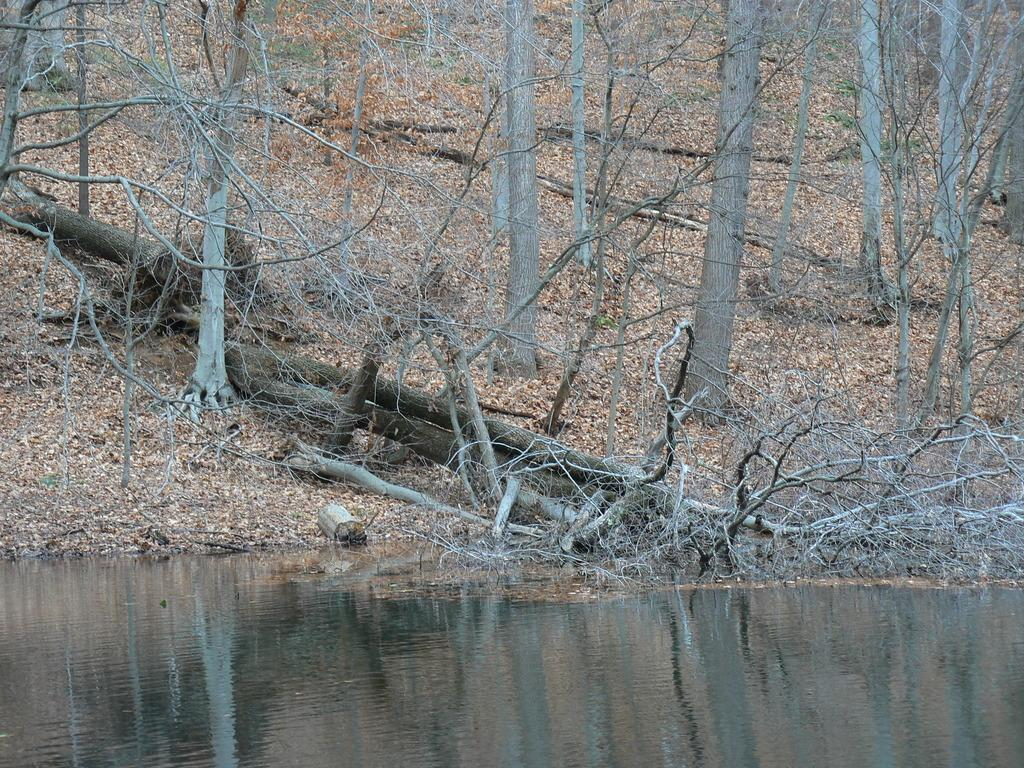What is the primary element visible in the image? There is water in the image. What can be seen growing near the water? There are branches and trees in the image. Can you describe the vegetation present in the image? The vegetation includes branches and trees. How many quarters can be seen floating in the water in the image? There are no quarters visible in the image; it only features water, branches, and trees. 